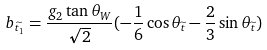Convert formula to latex. <formula><loc_0><loc_0><loc_500><loc_500>b _ { \widetilde { t _ { 1 } } } = \frac { g _ { 2 } \tan \theta _ { W } } { \sqrt { 2 } } ( - \frac { 1 } { 6 } \cos \theta _ { \widetilde { t } } - \frac { 2 } { 3 } \sin \theta _ { \widetilde { t } } )</formula> 